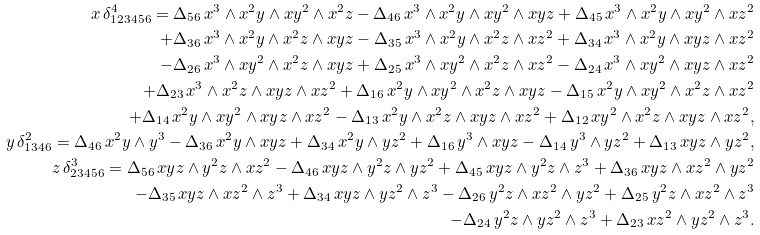<formula> <loc_0><loc_0><loc_500><loc_500>x \, \delta ^ { 4 } _ { 1 2 3 4 5 6 } = \Delta _ { 5 6 } \, x ^ { 3 } \wedge x ^ { 2 } y \wedge x y ^ { 2 } \wedge x ^ { 2 } z - \Delta _ { 4 6 } \, x ^ { 3 } \wedge x ^ { 2 } y \wedge x y ^ { 2 } \wedge x y z + \Delta _ { 4 5 } \, x ^ { 3 } \wedge x ^ { 2 } y \wedge x y ^ { 2 } \wedge x z ^ { 2 } \\ + \Delta _ { 3 6 } \, x ^ { 3 } \wedge x ^ { 2 } y \wedge x ^ { 2 } z \wedge x y z - \Delta _ { 3 5 } \, x ^ { 3 } \wedge x ^ { 2 } y \wedge x ^ { 2 } z \wedge x z ^ { 2 } + \Delta _ { 3 4 } \, x ^ { 3 } \wedge x ^ { 2 } y \wedge x y z \wedge x z ^ { 2 } \\ - \Delta _ { 2 6 } \, x ^ { 3 } \wedge x y ^ { 2 } \wedge x ^ { 2 } z \wedge x y z + \Delta _ { 2 5 } \, x ^ { 3 } \wedge x y ^ { 2 } \wedge x ^ { 2 } z \wedge x z ^ { 2 } - \Delta _ { 2 4 } \, x ^ { 3 } \wedge x y ^ { 2 } \wedge x y z \wedge x z ^ { 2 } \\ + \Delta _ { 2 3 } \, x ^ { 3 } \wedge x ^ { 2 } z \wedge x y z \wedge x z ^ { 2 } + \Delta _ { 1 6 } \, x ^ { 2 } y \wedge x y ^ { 2 } \wedge x ^ { 2 } z \wedge x y z - \Delta _ { 1 5 } \, x ^ { 2 } y \wedge x y ^ { 2 } \wedge x ^ { 2 } z \wedge x z ^ { 2 } \\ + \Delta _ { 1 4 } \, x ^ { 2 } y \wedge x y ^ { 2 } \wedge x y z \wedge x z ^ { 2 } - \Delta _ { 1 3 } \, x ^ { 2 } y \wedge x ^ { 2 } z \wedge x y z \wedge x z ^ { 2 } + \Delta _ { 1 2 } \, x y ^ { 2 } \wedge x ^ { 2 } z \wedge x y z \wedge x z ^ { 2 } , \\ y \, \delta ^ { 2 } _ { 1 3 4 6 } = \Delta _ { 4 6 } \, x ^ { 2 } y \wedge y ^ { 3 } - \Delta _ { 3 6 } \, x ^ { 2 } y \wedge x y z + \Delta _ { 3 4 } \, x ^ { 2 } y \wedge y z ^ { 2 } + \Delta _ { 1 6 } \, y ^ { 3 } \wedge x y z - \Delta _ { 1 4 } \, y ^ { 3 } \wedge y z ^ { 2 } + \Delta _ { 1 3 } \, x y z \wedge y z ^ { 2 } , \\ z \, \delta ^ { 3 } _ { 2 3 4 5 6 } = \Delta _ { 5 6 } \, x y z \wedge y ^ { 2 } z \wedge x z ^ { 2 } - \Delta _ { 4 6 } \, x y z \wedge y ^ { 2 } z \wedge y z ^ { 2 } + \Delta _ { 4 5 } \, x y z \wedge y ^ { 2 } z \wedge z ^ { 3 } + \Delta _ { 3 6 } \, x y z \wedge x z ^ { 2 } \wedge y z ^ { 2 } \\ - \Delta _ { 3 5 } \, x y z \wedge x z ^ { 2 } \wedge z ^ { 3 } + \Delta _ { 3 4 } \, x y z \wedge y z ^ { 2 } \wedge z ^ { 3 } - \Delta _ { 2 6 } \, y ^ { 2 } z \wedge x z ^ { 2 } \wedge y z ^ { 2 } + \Delta _ { 2 5 } \, y ^ { 2 } z \wedge x z ^ { 2 } \wedge z ^ { 3 } \\ - \Delta _ { 2 4 } \, y ^ { 2 } z \wedge y z ^ { 2 } \wedge z ^ { 3 } + \Delta _ { 2 3 } \, x z ^ { 2 } \wedge y z ^ { 2 } \wedge z ^ { 3 } .</formula> 